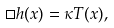<formula> <loc_0><loc_0><loc_500><loc_500>\Box h ( x ) = \kappa T ( x ) ,</formula> 